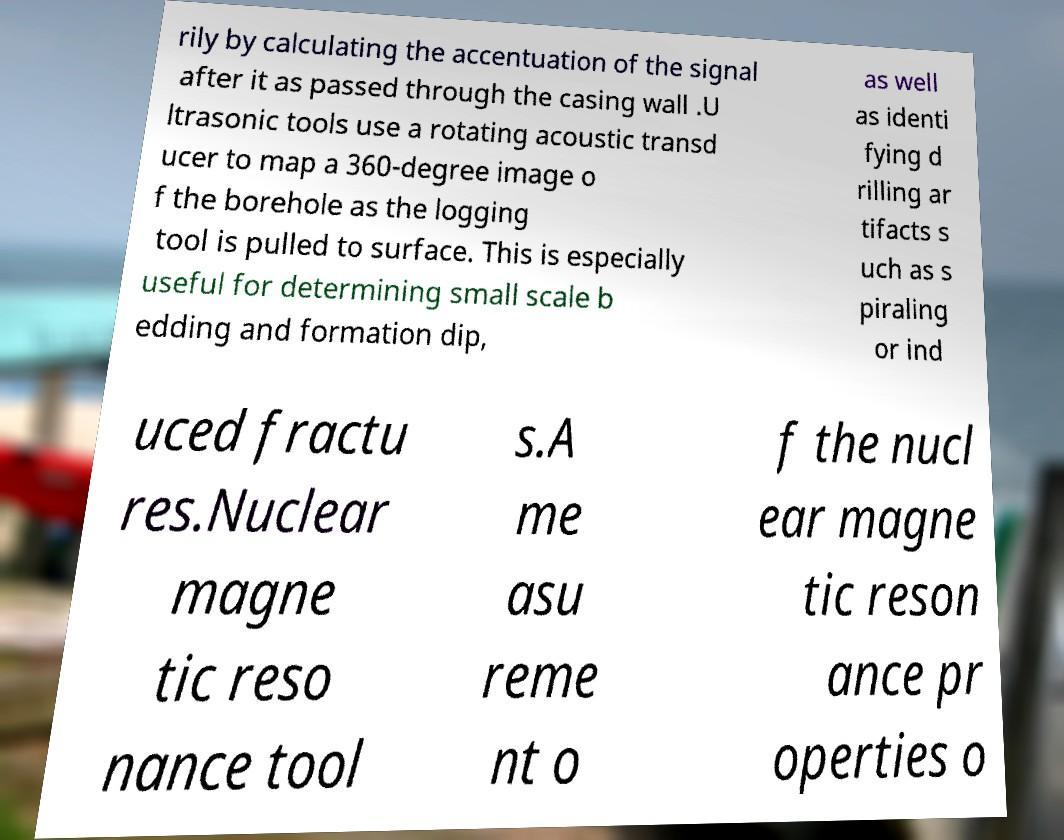Please identify and transcribe the text found in this image. rily by calculating the accentuation of the signal after it as passed through the casing wall .U ltrasonic tools use a rotating acoustic transd ucer to map a 360-degree image o f the borehole as the logging tool is pulled to surface. This is especially useful for determining small scale b edding and formation dip, as well as identi fying d rilling ar tifacts s uch as s piraling or ind uced fractu res.Nuclear magne tic reso nance tool s.A me asu reme nt o f the nucl ear magne tic reson ance pr operties o 